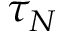<formula> <loc_0><loc_0><loc_500><loc_500>\tau _ { N }</formula> 